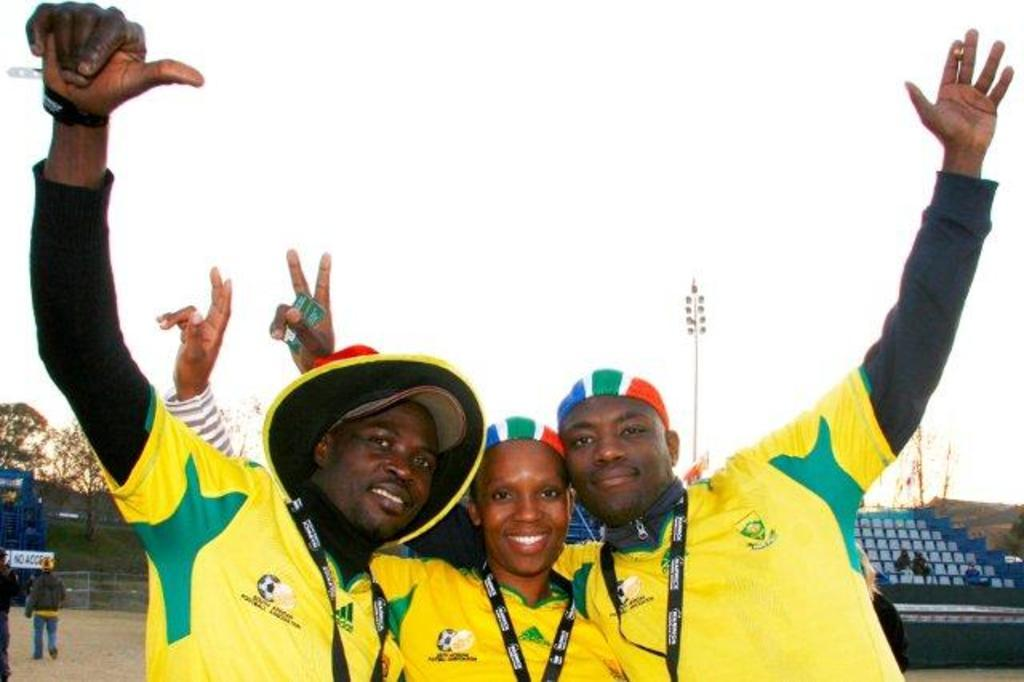How many people are in the image? There are people in the image, but the exact number is not specified. What are the people wearing in the image? Three people are wearing yellow color T-shirts in the image. What can be seen in the background of the image? There are chairs, trees, pole lights, and the sky visible in the background of the image. What type of stem can be seen growing from the ground in the image? There is no stem growing from the ground in the image. Are there any pets visible in the image? There is no mention of pets in the image. 